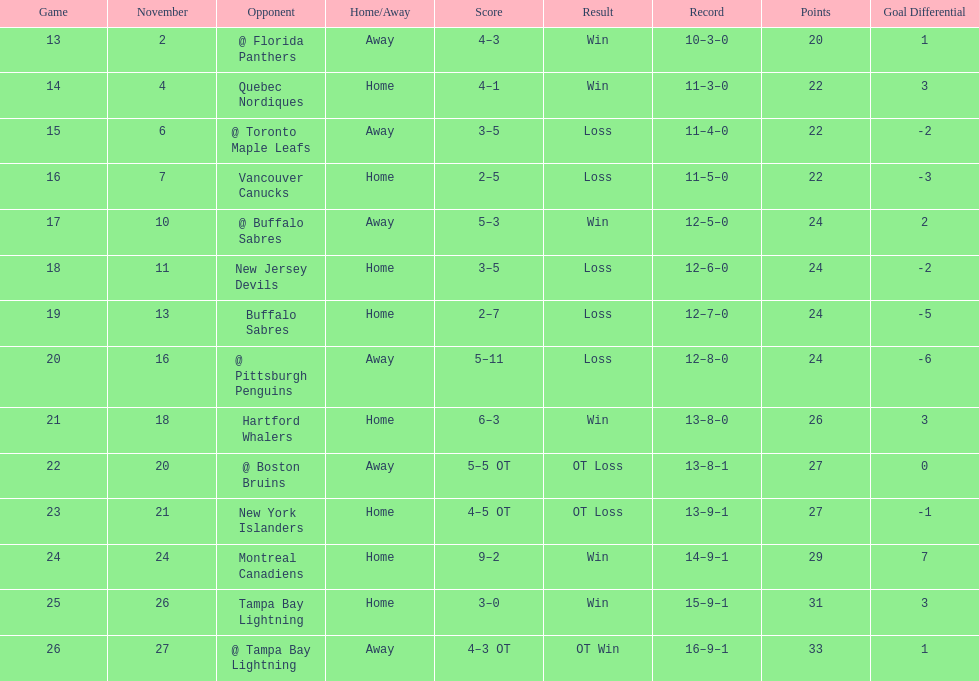Were the new jersey devils at the bottom of the chart? No. 